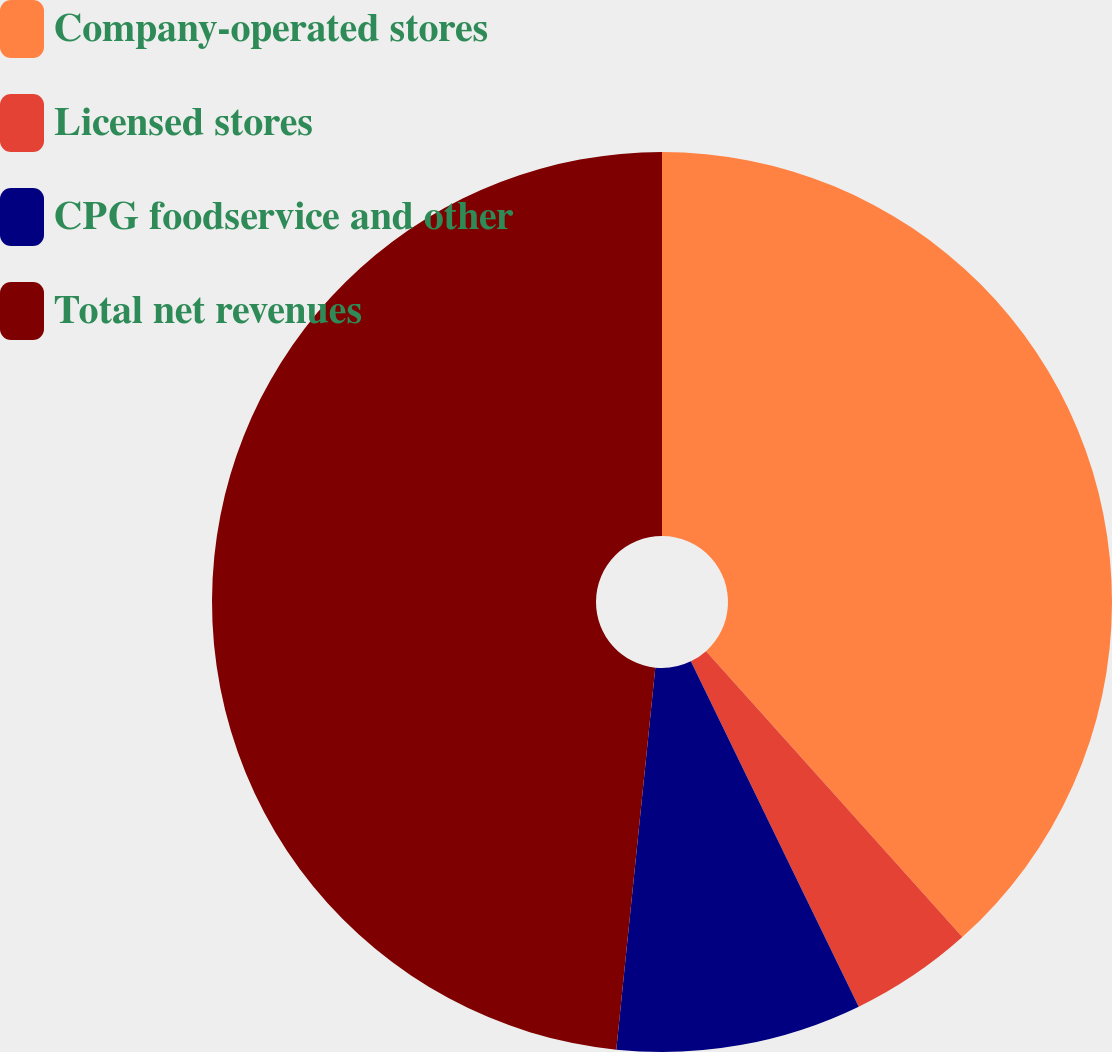Convert chart. <chart><loc_0><loc_0><loc_500><loc_500><pie_chart><fcel>Company-operated stores<fcel>Licensed stores<fcel>CPG foodservice and other<fcel>Total net revenues<nl><fcel>38.37%<fcel>4.43%<fcel>8.82%<fcel>48.38%<nl></chart> 